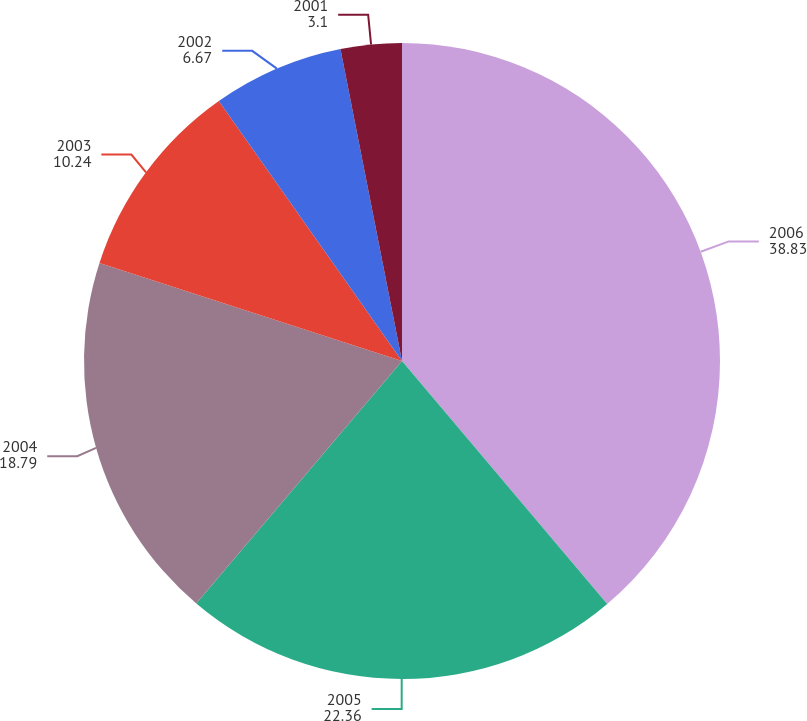Convert chart. <chart><loc_0><loc_0><loc_500><loc_500><pie_chart><fcel>2006<fcel>2005<fcel>2004<fcel>2003<fcel>2002<fcel>2001<nl><fcel>38.83%<fcel>22.36%<fcel>18.79%<fcel>10.24%<fcel>6.67%<fcel>3.1%<nl></chart> 